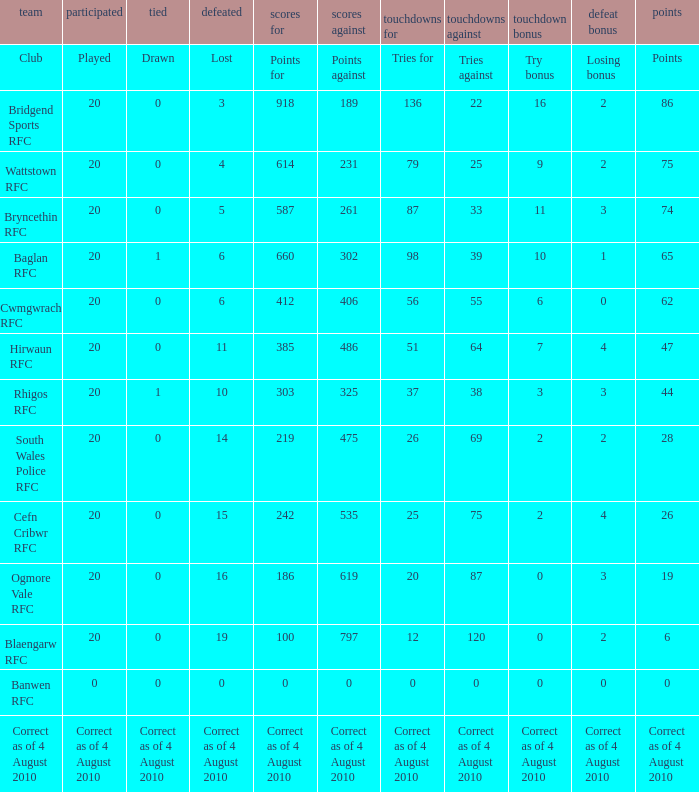When the club is hirwaun rfc, what is illustrated? 0.0. 